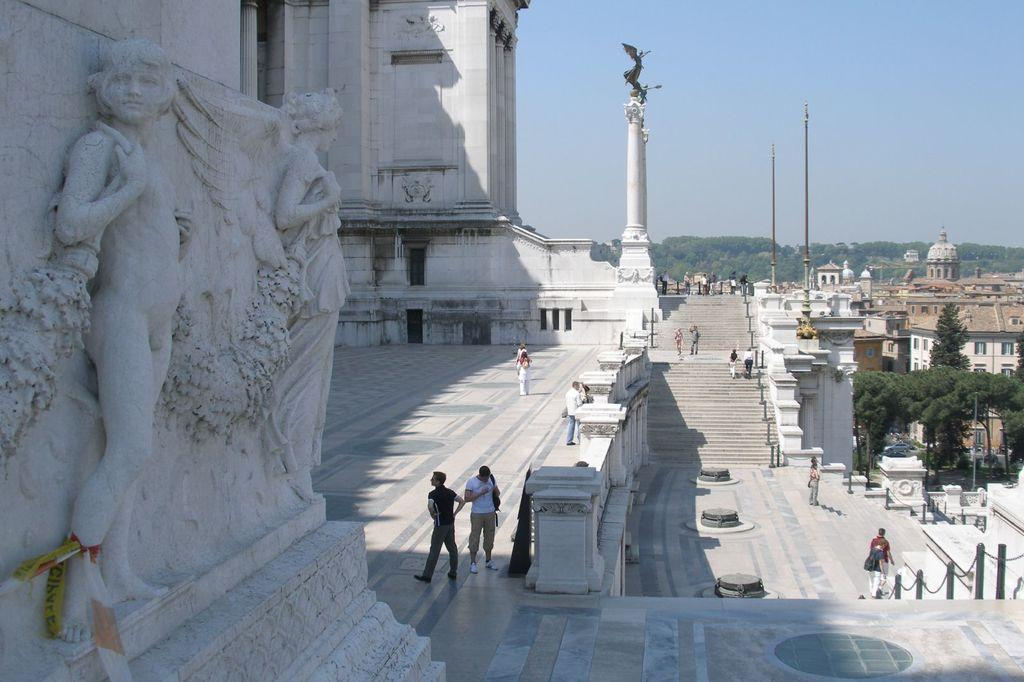What type of structures can be seen in the image? There are buildings in the image. What other elements are present in the image besides buildings? There are trees, poles, stairs, people, railings, and sculptures on the wall in the image. Can you describe the architectural features in the image? The image features railings and stairs. What is visible at the top of the image? The sky is visible at the top of the image. What is the chance of winning a prize at the attraction depicted in the image? There is no attraction present in the image, so it is not possible to determine the chance of winning a prize. How does the adjustment of the railings affect the overall design of the image? There is no mention of any adjustment to the railings in the image, so it is not possible to determine how it would affect the overall design. 